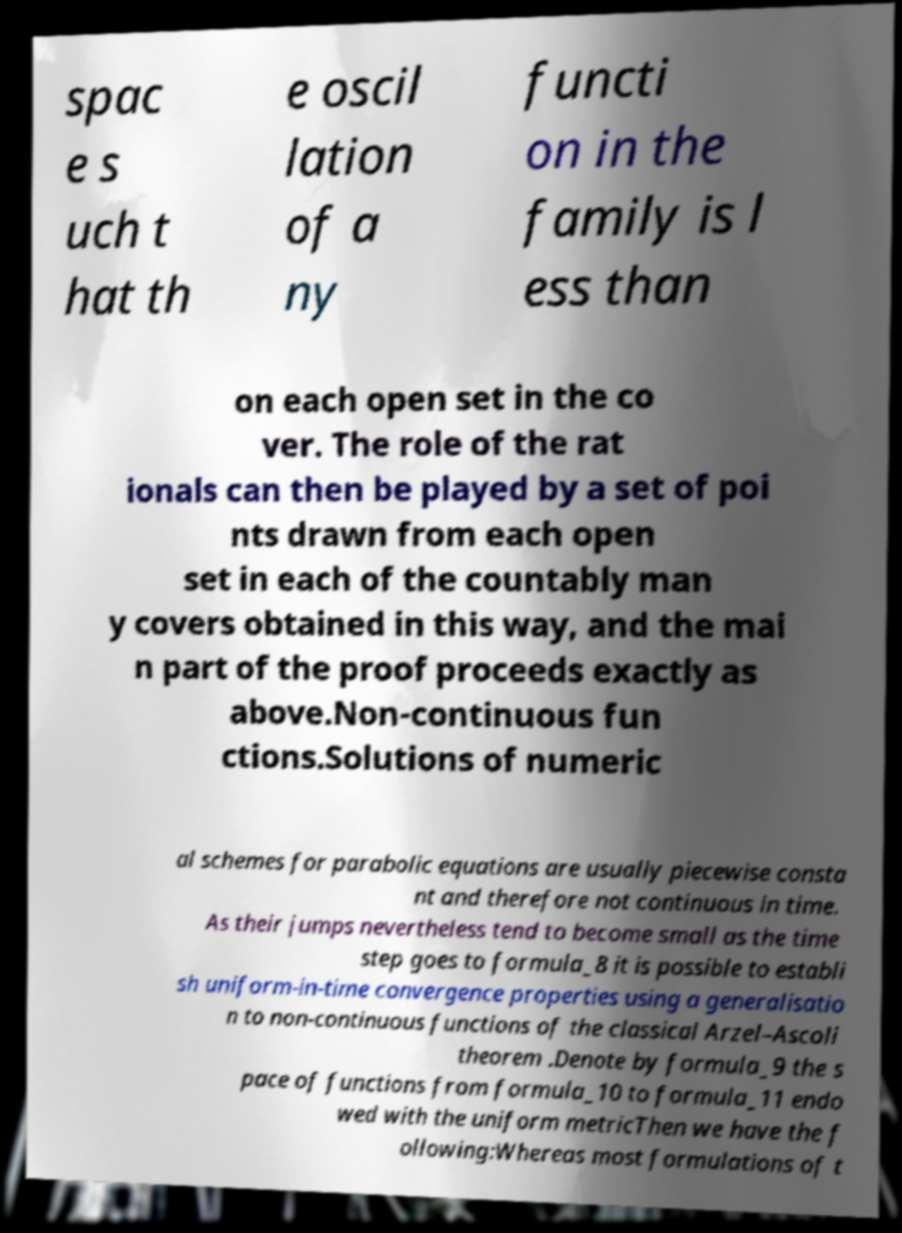For documentation purposes, I need the text within this image transcribed. Could you provide that? spac e s uch t hat th e oscil lation of a ny functi on in the family is l ess than on each open set in the co ver. The role of the rat ionals can then be played by a set of poi nts drawn from each open set in each of the countably man y covers obtained in this way, and the mai n part of the proof proceeds exactly as above.Non-continuous fun ctions.Solutions of numeric al schemes for parabolic equations are usually piecewise consta nt and therefore not continuous in time. As their jumps nevertheless tend to become small as the time step goes to formula_8 it is possible to establi sh uniform-in-time convergence properties using a generalisatio n to non-continuous functions of the classical Arzel–Ascoli theorem .Denote by formula_9 the s pace of functions from formula_10 to formula_11 endo wed with the uniform metricThen we have the f ollowing:Whereas most formulations of t 